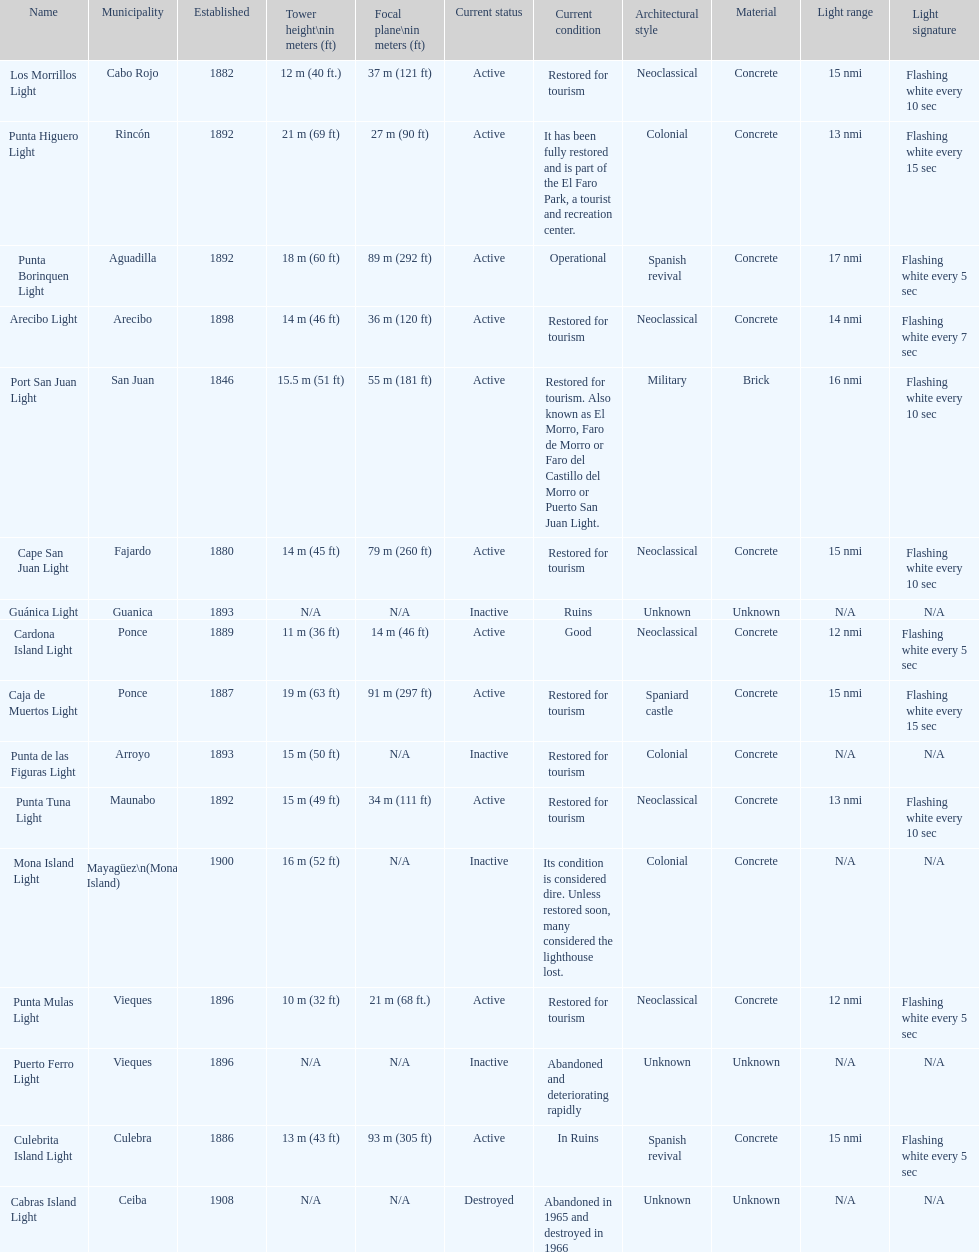Cardona island light and caja de muertos light are both located in what municipality? Ponce. 